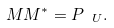<formula> <loc_0><loc_0><loc_500><loc_500>M M ^ { * } = P _ { \ U } .</formula> 